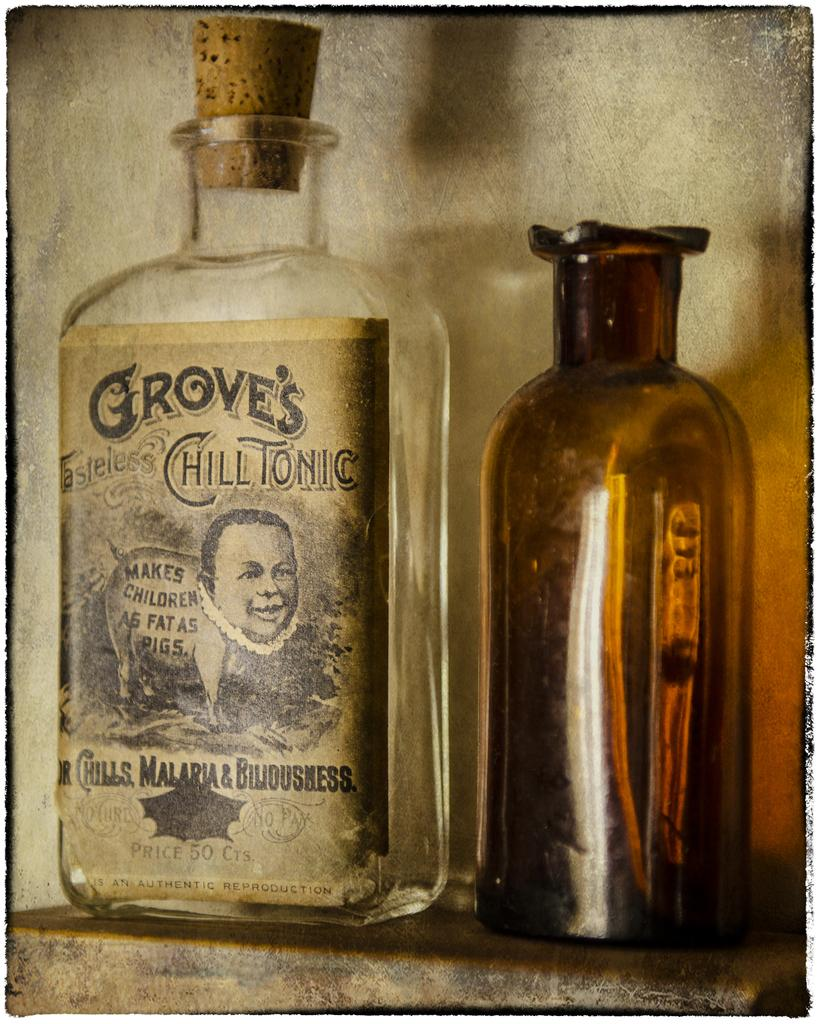How many glass bottles are in the image? There are two glass bottles in the image. What distinguishes the bottle on the left side from the other bottle? The bottle on the left side has a sticker attached to it and a cork. What can be seen in the background of the image? There is a wall visible in the background of the image. What type of silk is used to cover the bottles in the image? There is no silk present in the image; the bottles are made of glass and have a sticker and cork. 